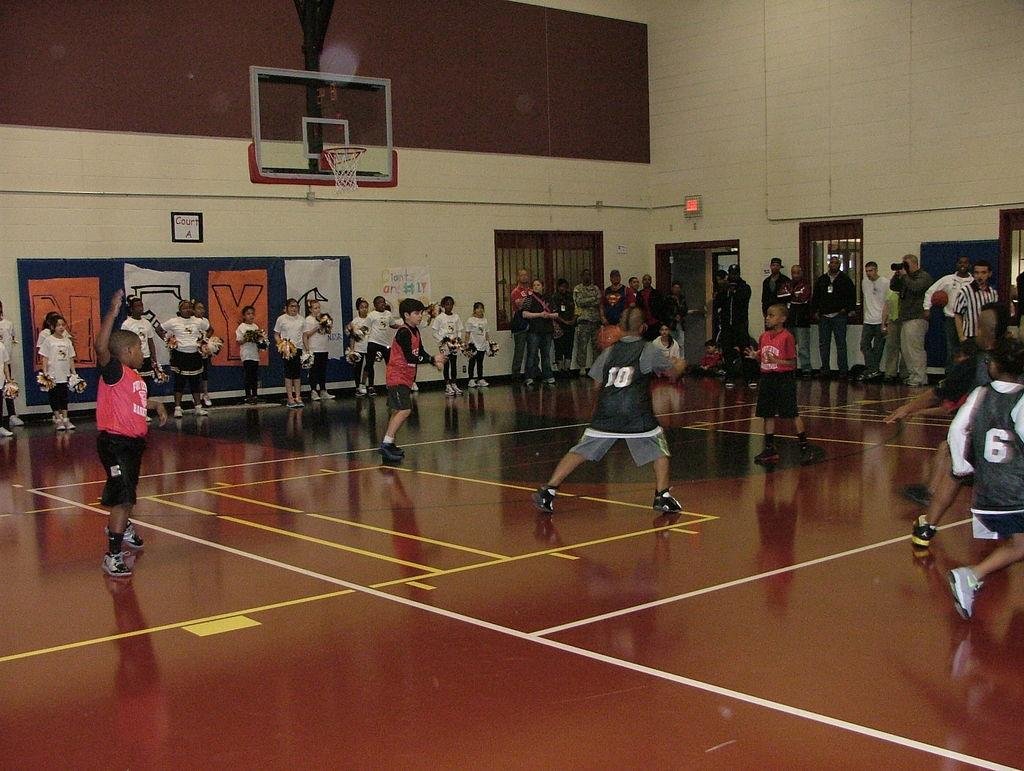<image>
Relay a brief, clear account of the picture shown. The kids are playing a basketball game on court A 